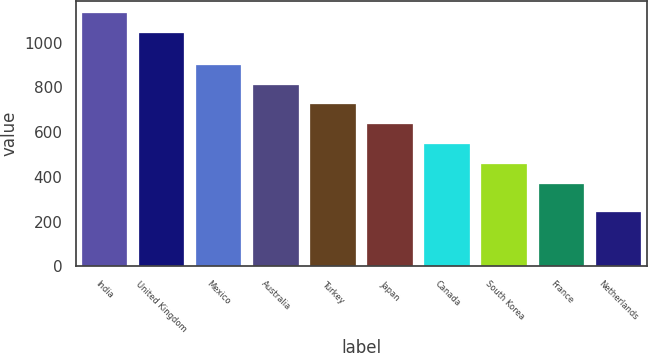Convert chart to OTSL. <chart><loc_0><loc_0><loc_500><loc_500><bar_chart><fcel>India<fcel>United Kingdom<fcel>Mexico<fcel>Australia<fcel>Turkey<fcel>Japan<fcel>Canada<fcel>South Korea<fcel>France<fcel>Netherlands<nl><fcel>1130.4<fcel>1042<fcel>900.4<fcel>812<fcel>723.6<fcel>635.2<fcel>546.8<fcel>458.4<fcel>370<fcel>242<nl></chart> 